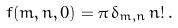<formula> <loc_0><loc_0><loc_500><loc_500>f ( m , n , 0 ) = \pi \, \delta _ { m , n } \, n ! \, .</formula> 